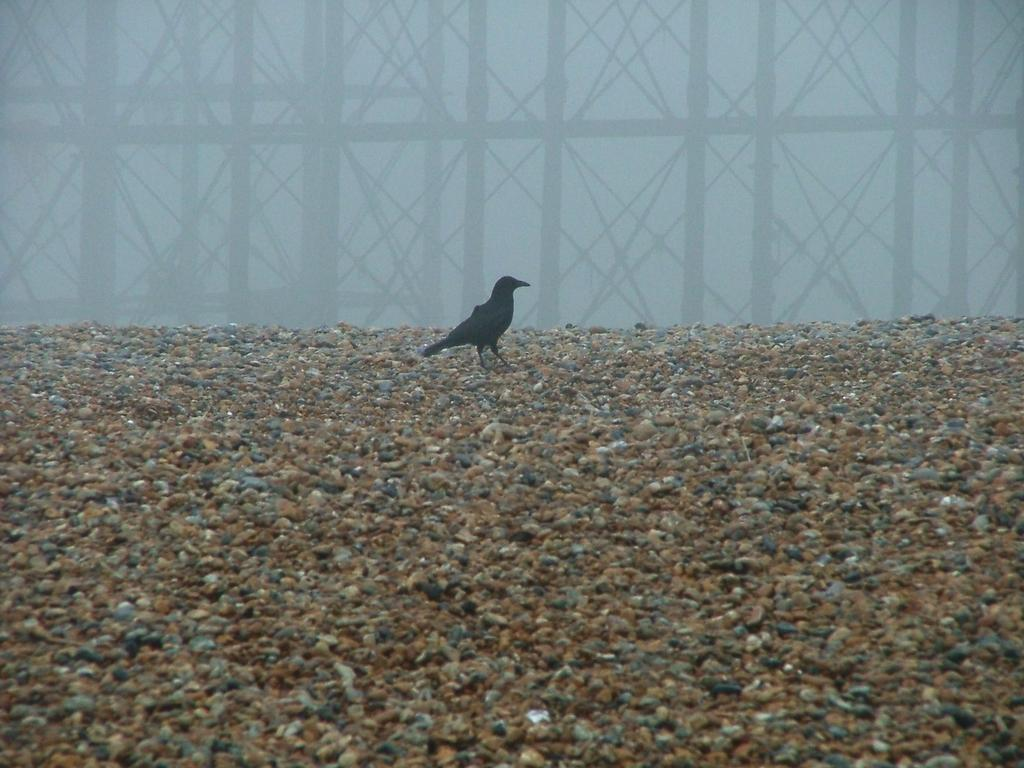What type of animal is in the image? There is a bird in the image. What color is the bird? The bird is black in color. What type of terrain is visible in the image? There is sand visible in the image. What structure can be seen in the image? There is a pole in the image. What type of underwear is the bird wearing in the image? There is no underwear present in the image, as birds do not wear clothing. 